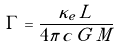Convert formula to latex. <formula><loc_0><loc_0><loc_500><loc_500>\Gamma = \frac { \kappa _ { e } \, L } { 4 \pi \, c \, G \, M }</formula> 